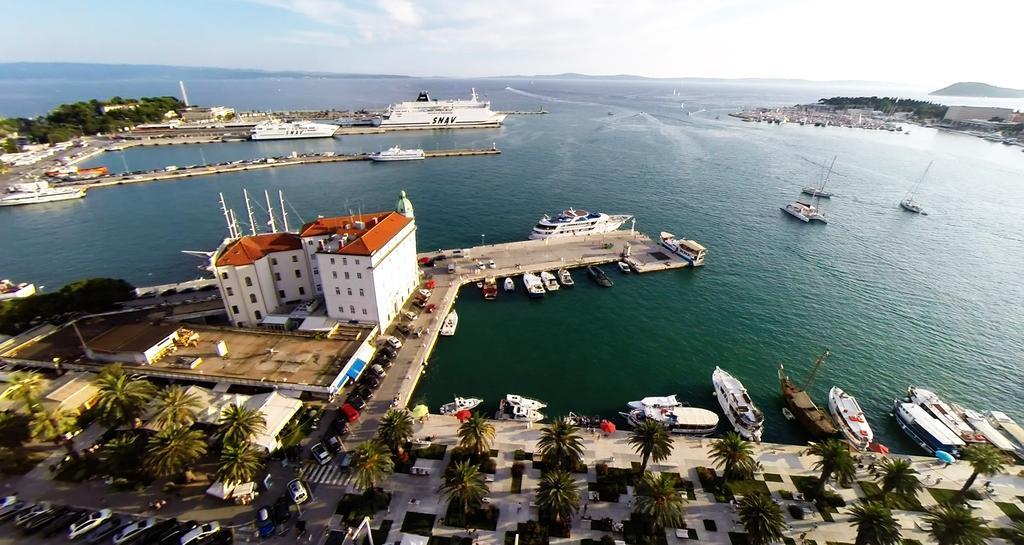In one or two sentences, can you explain what this image depicts? In this image I can see the ground, few vehicles, few trees, few persons, few buildings which are white and brown in color and few boats on the surface of the water. In the background I can see few trees, the water, few buildings, a ship which is white in color and the sky. 